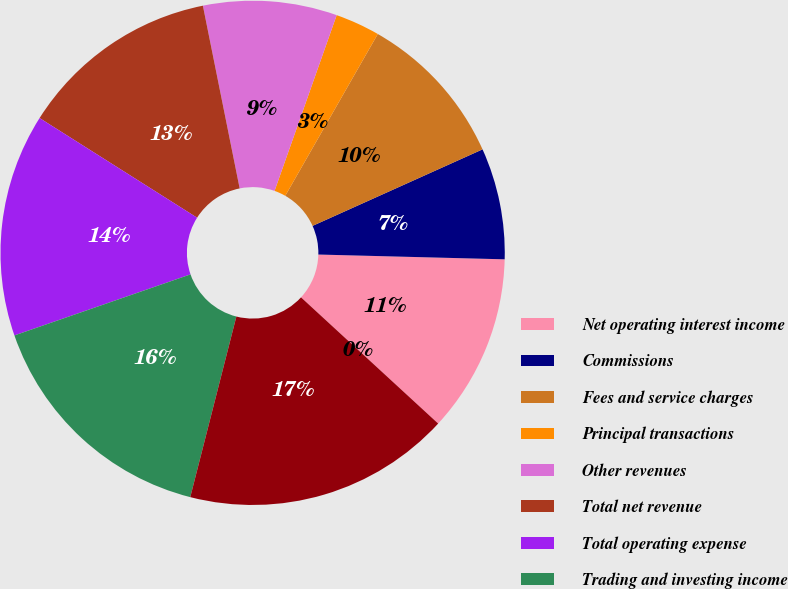Convert chart to OTSL. <chart><loc_0><loc_0><loc_500><loc_500><pie_chart><fcel>Net operating interest income<fcel>Commissions<fcel>Fees and service charges<fcel>Principal transactions<fcel>Other revenues<fcel>Total net revenue<fcel>Total operating expense<fcel>Trading and investing income<fcel>DARTs<fcel>Average commission per trade<nl><fcel>11.43%<fcel>7.14%<fcel>10.0%<fcel>2.86%<fcel>8.57%<fcel>12.86%<fcel>14.29%<fcel>15.71%<fcel>17.14%<fcel>0.0%<nl></chart> 